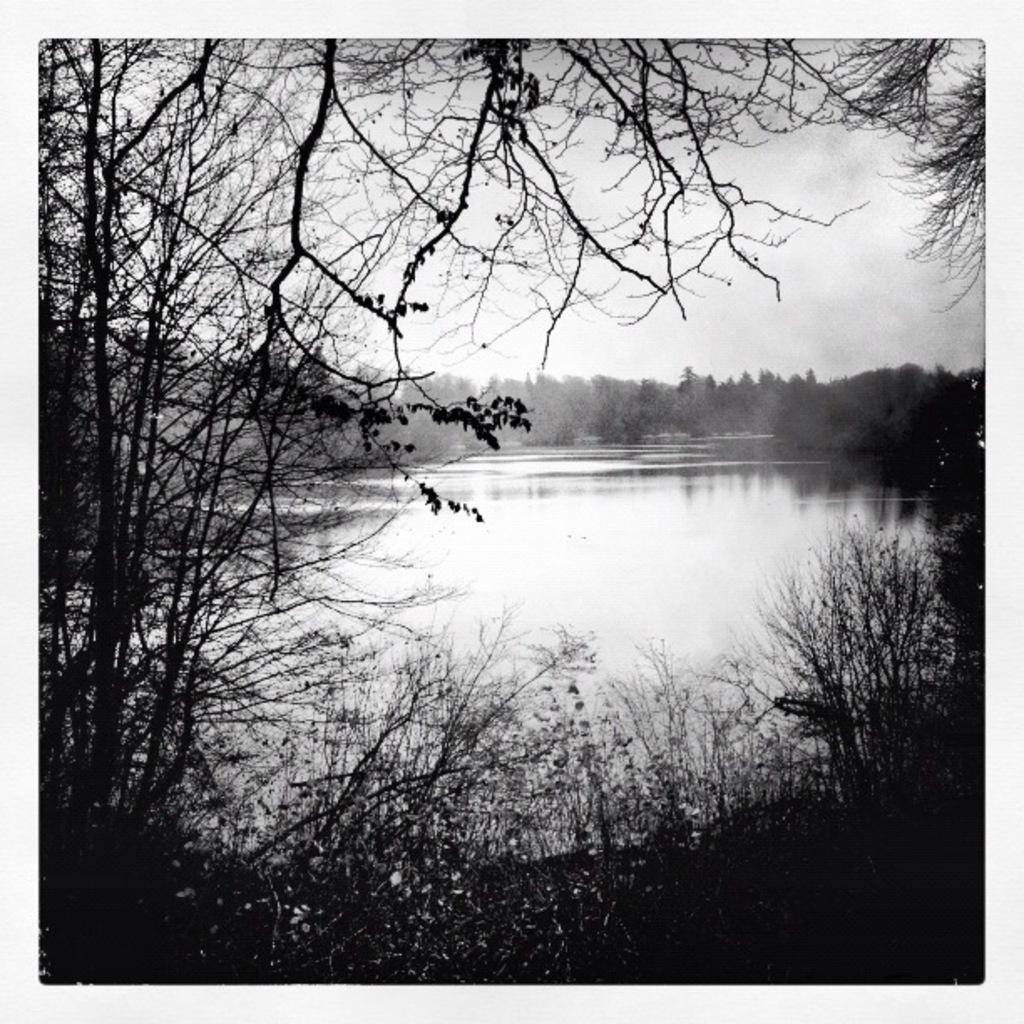What is the color scheme of the image? The image is black and white. What can be seen in the foreground of the image? There are trees in the front of the image. What is visible in the background of the image? There are trees and the sky visible in the background of the image. What type of leather is being used to design the trees in the image? There is no leather present in the image, as it features trees in a black and white color scheme. 